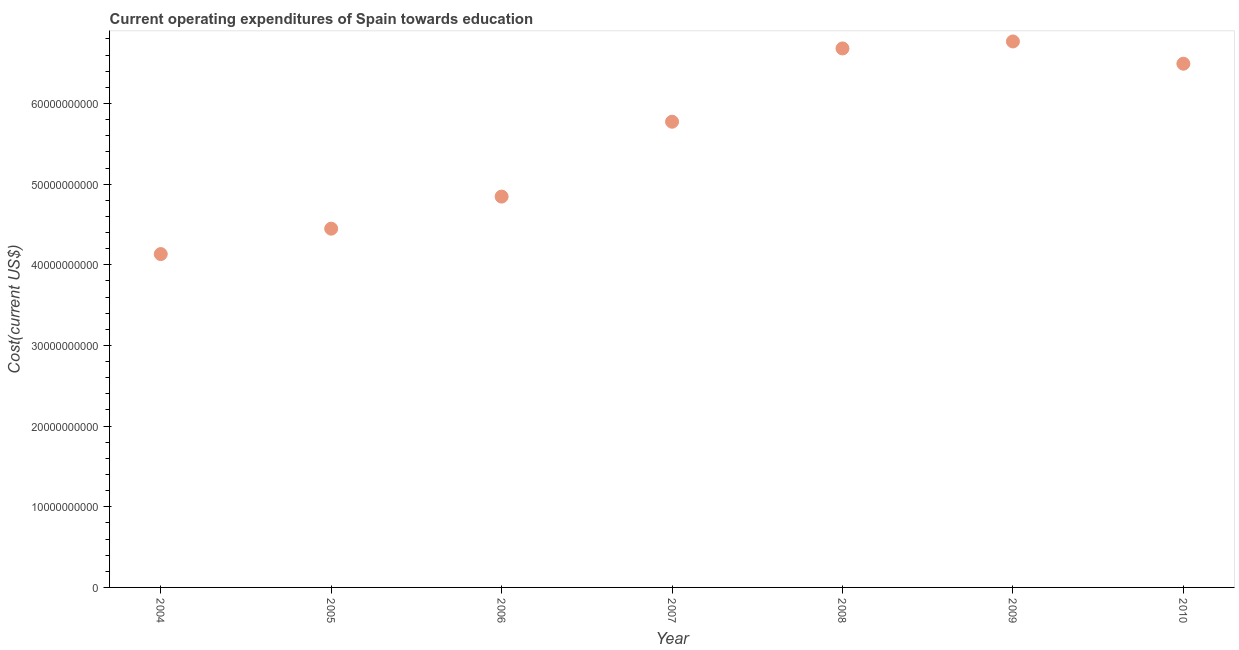What is the education expenditure in 2005?
Keep it short and to the point. 4.45e+1. Across all years, what is the maximum education expenditure?
Offer a terse response. 6.77e+1. Across all years, what is the minimum education expenditure?
Your answer should be compact. 4.13e+1. In which year was the education expenditure maximum?
Your answer should be compact. 2009. What is the sum of the education expenditure?
Offer a terse response. 3.91e+11. What is the difference between the education expenditure in 2006 and 2009?
Offer a very short reply. -1.92e+1. What is the average education expenditure per year?
Provide a short and direct response. 5.59e+1. What is the median education expenditure?
Give a very brief answer. 5.77e+1. What is the ratio of the education expenditure in 2006 to that in 2007?
Give a very brief answer. 0.84. Is the education expenditure in 2006 less than that in 2010?
Your answer should be compact. Yes. What is the difference between the highest and the second highest education expenditure?
Provide a succinct answer. 8.66e+08. What is the difference between the highest and the lowest education expenditure?
Your answer should be very brief. 2.64e+1. How many dotlines are there?
Keep it short and to the point. 1. How many years are there in the graph?
Provide a short and direct response. 7. What is the difference between two consecutive major ticks on the Y-axis?
Offer a very short reply. 1.00e+1. Does the graph contain any zero values?
Provide a short and direct response. No. Does the graph contain grids?
Ensure brevity in your answer.  No. What is the title of the graph?
Provide a short and direct response. Current operating expenditures of Spain towards education. What is the label or title of the Y-axis?
Offer a very short reply. Cost(current US$). What is the Cost(current US$) in 2004?
Ensure brevity in your answer.  4.13e+1. What is the Cost(current US$) in 2005?
Ensure brevity in your answer.  4.45e+1. What is the Cost(current US$) in 2006?
Your answer should be compact. 4.85e+1. What is the Cost(current US$) in 2007?
Give a very brief answer. 5.77e+1. What is the Cost(current US$) in 2008?
Provide a succinct answer. 6.68e+1. What is the Cost(current US$) in 2009?
Provide a succinct answer. 6.77e+1. What is the Cost(current US$) in 2010?
Offer a terse response. 6.49e+1. What is the difference between the Cost(current US$) in 2004 and 2005?
Provide a short and direct response. -3.15e+09. What is the difference between the Cost(current US$) in 2004 and 2006?
Make the answer very short. -7.13e+09. What is the difference between the Cost(current US$) in 2004 and 2007?
Your response must be concise. -1.64e+1. What is the difference between the Cost(current US$) in 2004 and 2008?
Give a very brief answer. -2.55e+1. What is the difference between the Cost(current US$) in 2004 and 2009?
Keep it short and to the point. -2.64e+1. What is the difference between the Cost(current US$) in 2004 and 2010?
Make the answer very short. -2.36e+1. What is the difference between the Cost(current US$) in 2005 and 2006?
Offer a very short reply. -3.98e+09. What is the difference between the Cost(current US$) in 2005 and 2007?
Ensure brevity in your answer.  -1.33e+1. What is the difference between the Cost(current US$) in 2005 and 2008?
Keep it short and to the point. -2.23e+1. What is the difference between the Cost(current US$) in 2005 and 2009?
Ensure brevity in your answer.  -2.32e+1. What is the difference between the Cost(current US$) in 2005 and 2010?
Your answer should be compact. -2.05e+1. What is the difference between the Cost(current US$) in 2006 and 2007?
Offer a terse response. -9.28e+09. What is the difference between the Cost(current US$) in 2006 and 2008?
Provide a short and direct response. -1.84e+1. What is the difference between the Cost(current US$) in 2006 and 2009?
Your answer should be compact. -1.92e+1. What is the difference between the Cost(current US$) in 2006 and 2010?
Make the answer very short. -1.65e+1. What is the difference between the Cost(current US$) in 2007 and 2008?
Offer a terse response. -9.08e+09. What is the difference between the Cost(current US$) in 2007 and 2009?
Provide a short and direct response. -9.95e+09. What is the difference between the Cost(current US$) in 2007 and 2010?
Offer a terse response. -7.19e+09. What is the difference between the Cost(current US$) in 2008 and 2009?
Make the answer very short. -8.66e+08. What is the difference between the Cost(current US$) in 2008 and 2010?
Give a very brief answer. 1.89e+09. What is the difference between the Cost(current US$) in 2009 and 2010?
Ensure brevity in your answer.  2.76e+09. What is the ratio of the Cost(current US$) in 2004 to that in 2005?
Make the answer very short. 0.93. What is the ratio of the Cost(current US$) in 2004 to that in 2006?
Provide a succinct answer. 0.85. What is the ratio of the Cost(current US$) in 2004 to that in 2007?
Offer a terse response. 0.72. What is the ratio of the Cost(current US$) in 2004 to that in 2008?
Keep it short and to the point. 0.62. What is the ratio of the Cost(current US$) in 2004 to that in 2009?
Give a very brief answer. 0.61. What is the ratio of the Cost(current US$) in 2004 to that in 2010?
Your response must be concise. 0.64. What is the ratio of the Cost(current US$) in 2005 to that in 2006?
Provide a succinct answer. 0.92. What is the ratio of the Cost(current US$) in 2005 to that in 2007?
Keep it short and to the point. 0.77. What is the ratio of the Cost(current US$) in 2005 to that in 2008?
Offer a terse response. 0.67. What is the ratio of the Cost(current US$) in 2005 to that in 2009?
Your answer should be very brief. 0.66. What is the ratio of the Cost(current US$) in 2005 to that in 2010?
Keep it short and to the point. 0.69. What is the ratio of the Cost(current US$) in 2006 to that in 2007?
Your answer should be compact. 0.84. What is the ratio of the Cost(current US$) in 2006 to that in 2008?
Give a very brief answer. 0.72. What is the ratio of the Cost(current US$) in 2006 to that in 2009?
Ensure brevity in your answer.  0.72. What is the ratio of the Cost(current US$) in 2006 to that in 2010?
Make the answer very short. 0.75. What is the ratio of the Cost(current US$) in 2007 to that in 2008?
Your answer should be compact. 0.86. What is the ratio of the Cost(current US$) in 2007 to that in 2009?
Give a very brief answer. 0.85. What is the ratio of the Cost(current US$) in 2007 to that in 2010?
Offer a terse response. 0.89. What is the ratio of the Cost(current US$) in 2008 to that in 2009?
Make the answer very short. 0.99. What is the ratio of the Cost(current US$) in 2009 to that in 2010?
Make the answer very short. 1.04. 